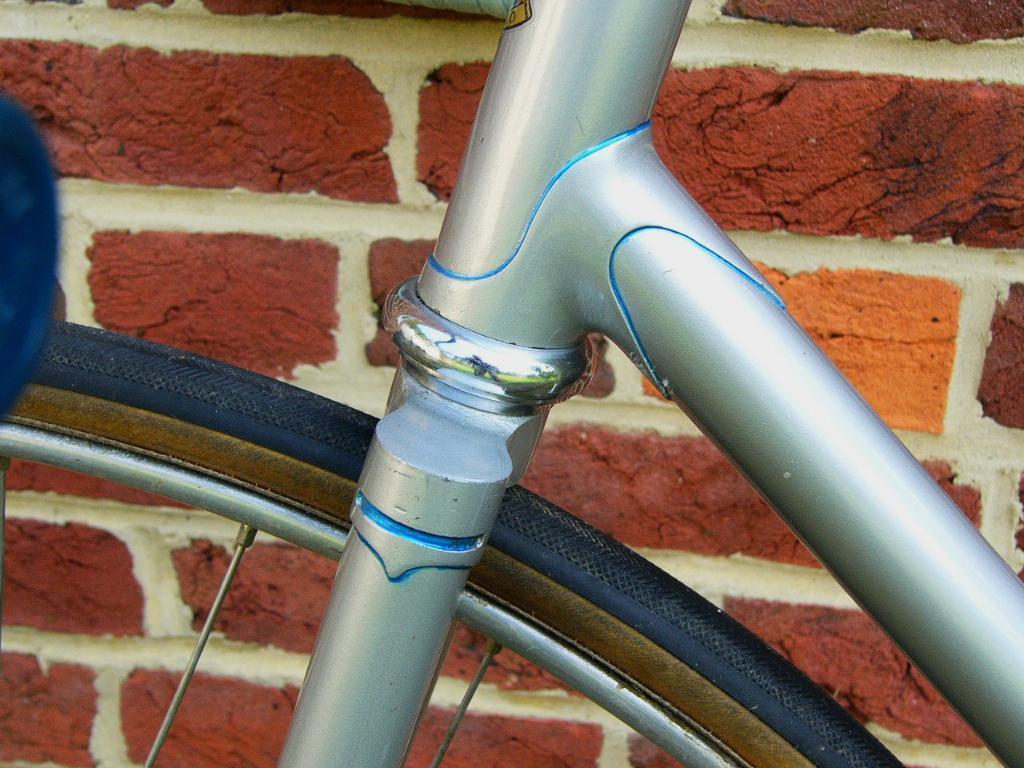How would you summarize this image in a sentence or two? In this picture we can see metal rods and a bicycle wheel. 